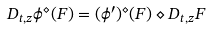Convert formula to latex. <formula><loc_0><loc_0><loc_500><loc_500>D _ { t , z } \phi ^ { \diamond } ( F ) = ( \phi ^ { \prime } ) ^ { \diamond } ( F ) \diamond D _ { t , z } F</formula> 